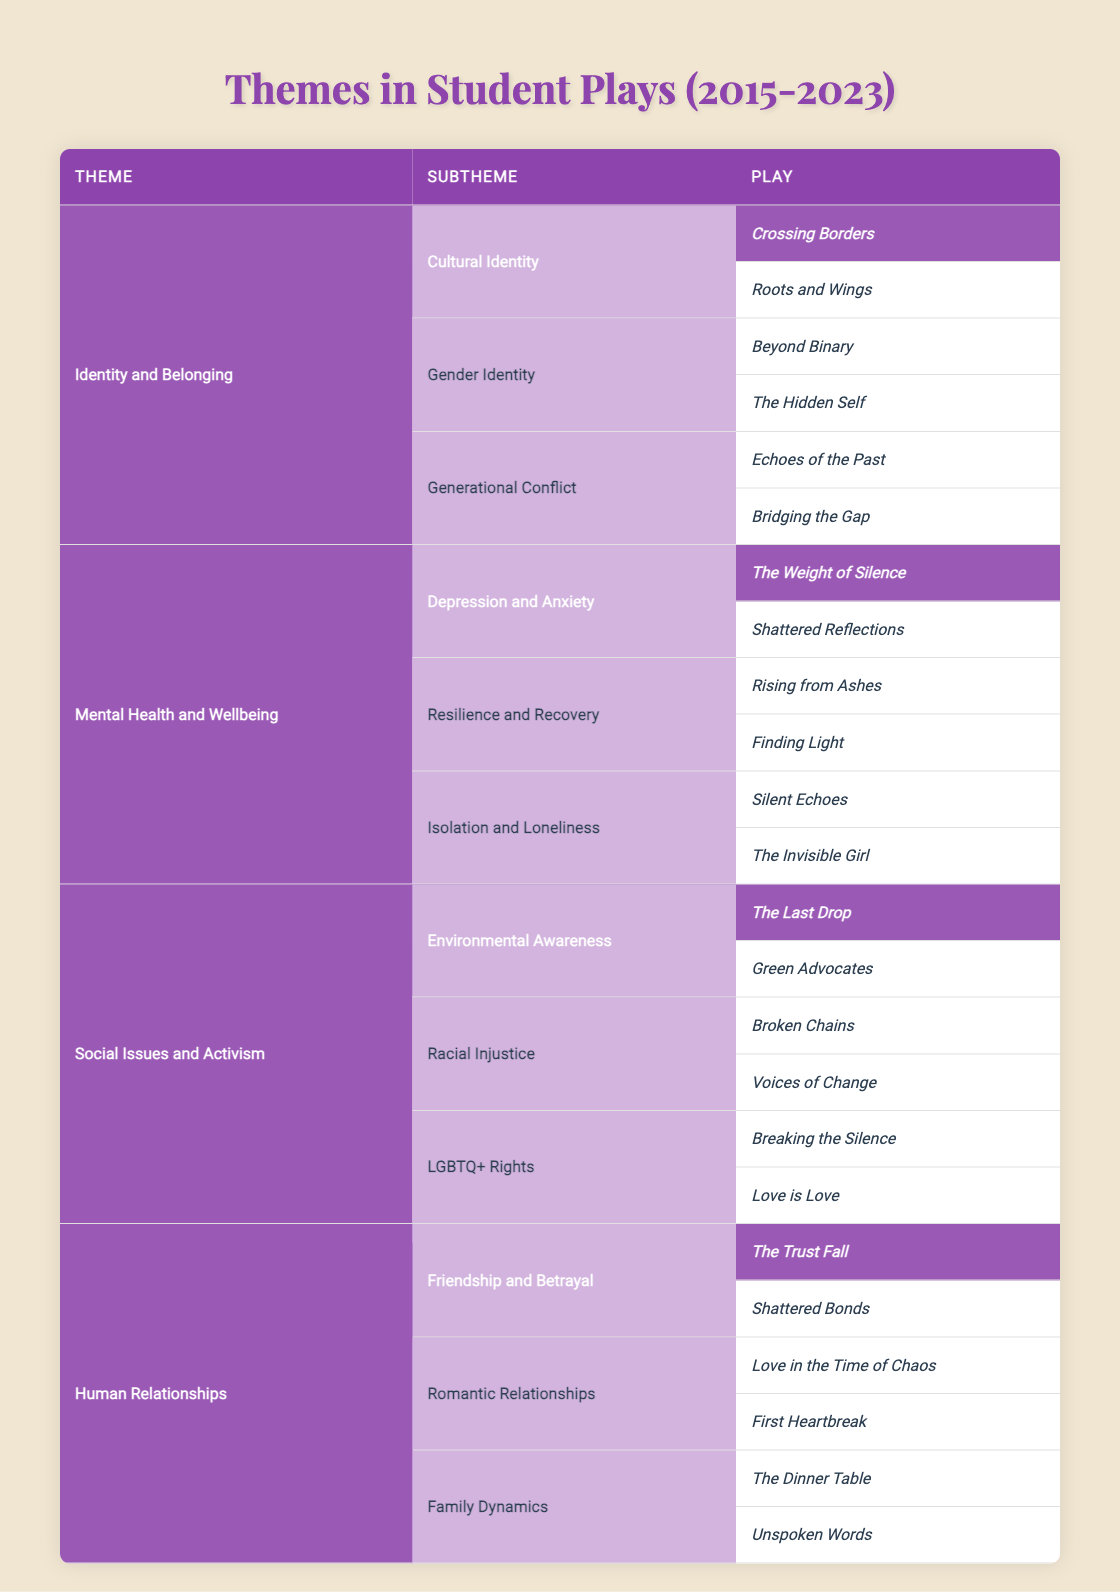What are the subthemes under the theme "Mental Health and Wellbeing"? The table lists three subthemes under "Mental Health and Wellbeing": Depression and Anxiety, Resilience and Recovery, and Isolation and Loneliness.
Answer: Depression and Anxiety, Resilience and Recovery, Isolation and Loneliness How many plays are associated with the subtheme "Cultural Identity"? There are two plays associated with the subtheme "Cultural Identity": Crossing Borders and Roots and Wings.
Answer: 2 Is "Love is Love" part of any theme or subtheme? Yes, "Love is Love" is listed under the subtheme "LGBTQ+ Rights," which is part of the theme "Social Issues and Activism."
Answer: Yes Which theme has the most plays listed? The theme "Identity and Belonging" and "Mental Health and Wellbeing" both have a total of six plays listed, while "Social Issues and Activism" and "Human Relationships" each have six plays as well, making them the themes with the most plays.
Answer: Identity and Belonging, Mental Health and Wellbeing, Social Issues and Activism, Human Relationships What is the relationship between the themes "Human Relationships" and "Mental Health and Wellbeing"? The theme "Human Relationships" explores interpersonal dynamics, while "Mental Health and Wellbeing" addresses psychological aspects. Both themes include emotions and experiences that can influence each other. For example, plays about family dynamics may delve into mental health issues such as resilience or isolation.
Answer: They are interrelated as both explore aspects of human experience 